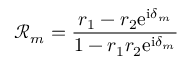Convert formula to latex. <formula><loc_0><loc_0><loc_500><loc_500>\mathcal { R } _ { m } = \frac { r _ { 1 } - r _ { 2 } e ^ { i \delta _ { m } } } { 1 - r _ { 1 } r _ { 2 } e ^ { i \delta _ { m } } }</formula> 